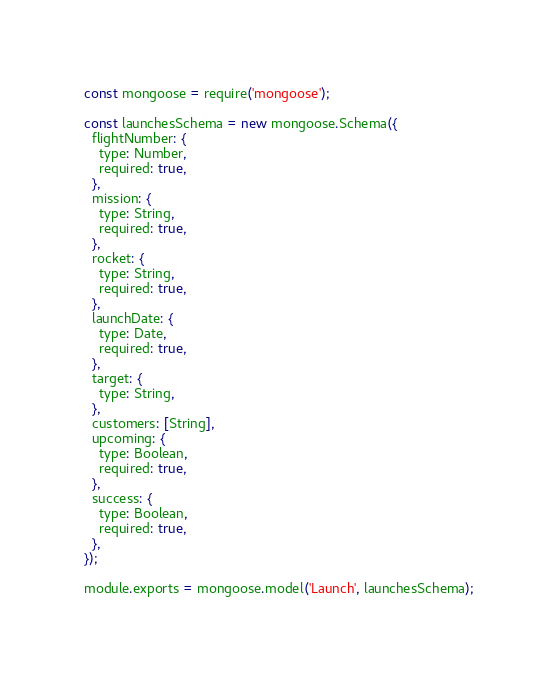<code> <loc_0><loc_0><loc_500><loc_500><_JavaScript_>const mongoose = require('mongoose');

const launchesSchema = new mongoose.Schema({
  flightNumber: {
    type: Number,
    required: true,
  },
  mission: {
    type: String,
    required: true,
  },
  rocket: {
    type: String,
    required: true,
  },
  launchDate: {
    type: Date,
    required: true,
  },
  target: {
    type: String,
  },
  customers: [String],
  upcoming: {
    type: Boolean,
    required: true,
  },
  success: {
    type: Boolean,
    required: true,
  },
});

module.exports = mongoose.model('Launch', launchesSchema);
</code> 